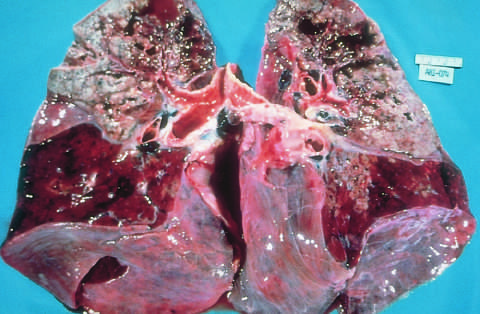what are riddled with gray-white areas of caseation and multiple areas of softening and cavitation?
Answer the question using a single word or phrase. The upper parts of both lungs 